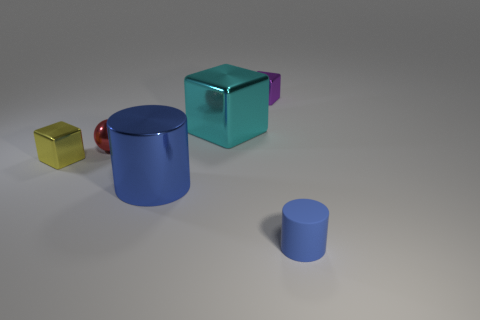What number of other objects are there of the same material as the yellow block?
Offer a terse response. 4. There is a big metallic object that is on the right side of the blue metal cylinder; does it have the same shape as the big object that is in front of the yellow metal thing?
Your answer should be very brief. No. Are the big blue cylinder and the large cyan block made of the same material?
Offer a terse response. Yes. How big is the blue cylinder in front of the blue thing left of the small purple object that is to the left of the tiny matte thing?
Give a very brief answer. Small. What number of other objects are the same color as the tiny cylinder?
Offer a terse response. 1. There is a blue thing that is the same size as the sphere; what shape is it?
Make the answer very short. Cylinder. What number of small objects are either brown matte spheres or matte things?
Offer a very short reply. 1. Is there a tiny purple metal object behind the tiny metal block that is to the right of the tiny block in front of the small purple object?
Your answer should be compact. No. Are there any blue metal things that have the same size as the blue metal cylinder?
Provide a succinct answer. No. There is a block that is the same size as the purple shiny thing; what material is it?
Offer a terse response. Metal. 